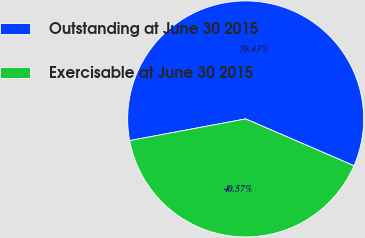<chart> <loc_0><loc_0><loc_500><loc_500><pie_chart><fcel>Outstanding at June 30 2015<fcel>Exercisable at June 30 2015<nl><fcel>59.43%<fcel>40.57%<nl></chart> 